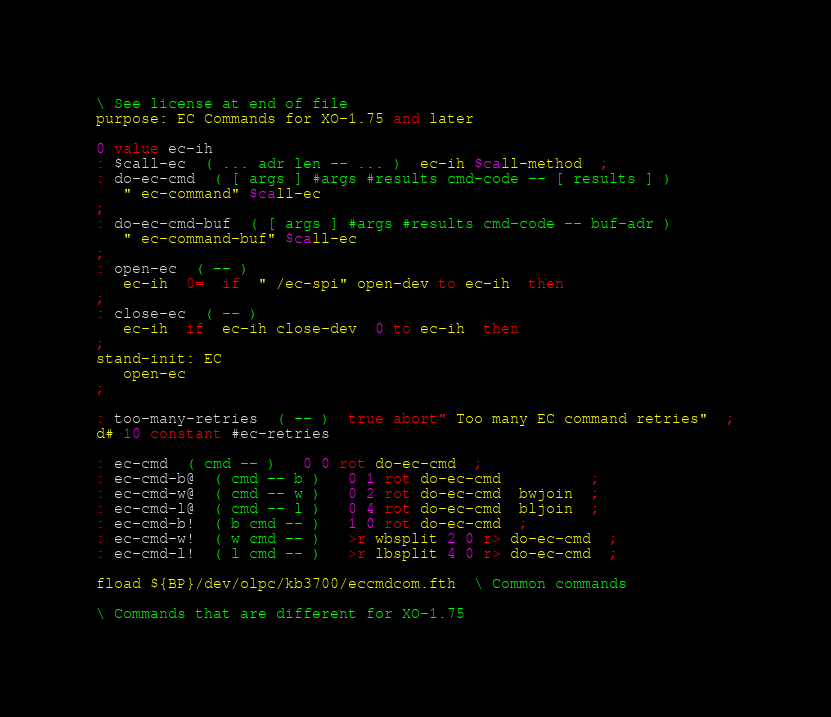<code> <loc_0><loc_0><loc_500><loc_500><_Forth_>\ See license at end of file
purpose: EC Commands for XO-1.75 and later

0 value ec-ih
: $call-ec  ( ... adr len -- ... )  ec-ih $call-method  ;
: do-ec-cmd  ( [ args ] #args #results cmd-code -- [ results ] )
   " ec-command" $call-ec
;
: do-ec-cmd-buf  ( [ args ] #args #results cmd-code -- buf-adr )
   " ec-command-buf" $call-ec
;
: open-ec  ( -- )
   ec-ih  0=  if  " /ec-spi" open-dev to ec-ih  then
;
: close-ec  ( -- )
   ec-ih  if  ec-ih close-dev  0 to ec-ih  then
;
stand-init: EC
   open-ec
;

: too-many-retries  ( -- )  true abort" Too many EC command retries"  ;
d# 10 constant #ec-retries

: ec-cmd  ( cmd -- )   0 0 rot do-ec-cmd  ;
: ec-cmd-b@  ( cmd -- b )   0 1 rot do-ec-cmd          ;
: ec-cmd-w@  ( cmd -- w )   0 2 rot do-ec-cmd  bwjoin  ;
: ec-cmd-l@  ( cmd -- l )   0 4 rot do-ec-cmd  bljoin  ;
: ec-cmd-b!  ( b cmd -- )   1 0 rot do-ec-cmd  ;
: ec-cmd-w!  ( w cmd -- )   >r wbsplit 2 0 r> do-ec-cmd  ;
: ec-cmd-l!  ( l cmd -- )   >r lbsplit 4 0 r> do-ec-cmd  ;

fload ${BP}/dev/olpc/kb3700/eccmdcom.fth  \ Common commands

\ Commands that are different for XO-1.75</code> 